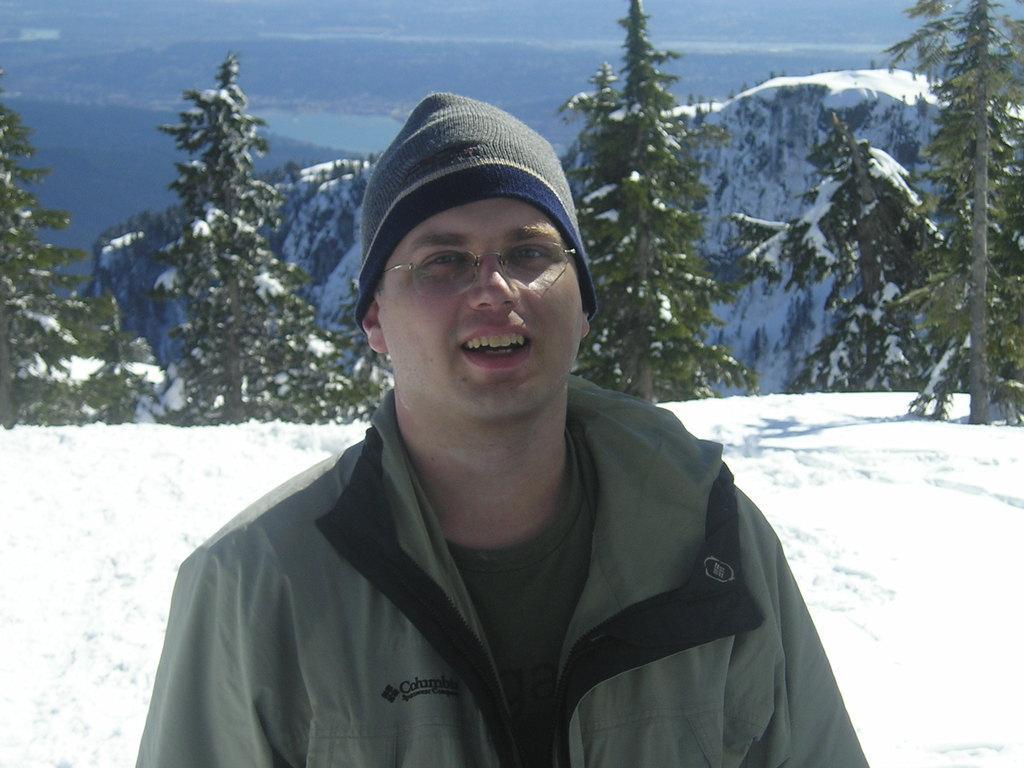Could you give a brief overview of what you see in this image? In this image we can see a man in the center. He is wearing a jacket and here we can see a monkey cap on his head. Here we can see the spectacles. Here we can see the snow. In the background, we can see the mountains and trees. This is a sky with clouds. 